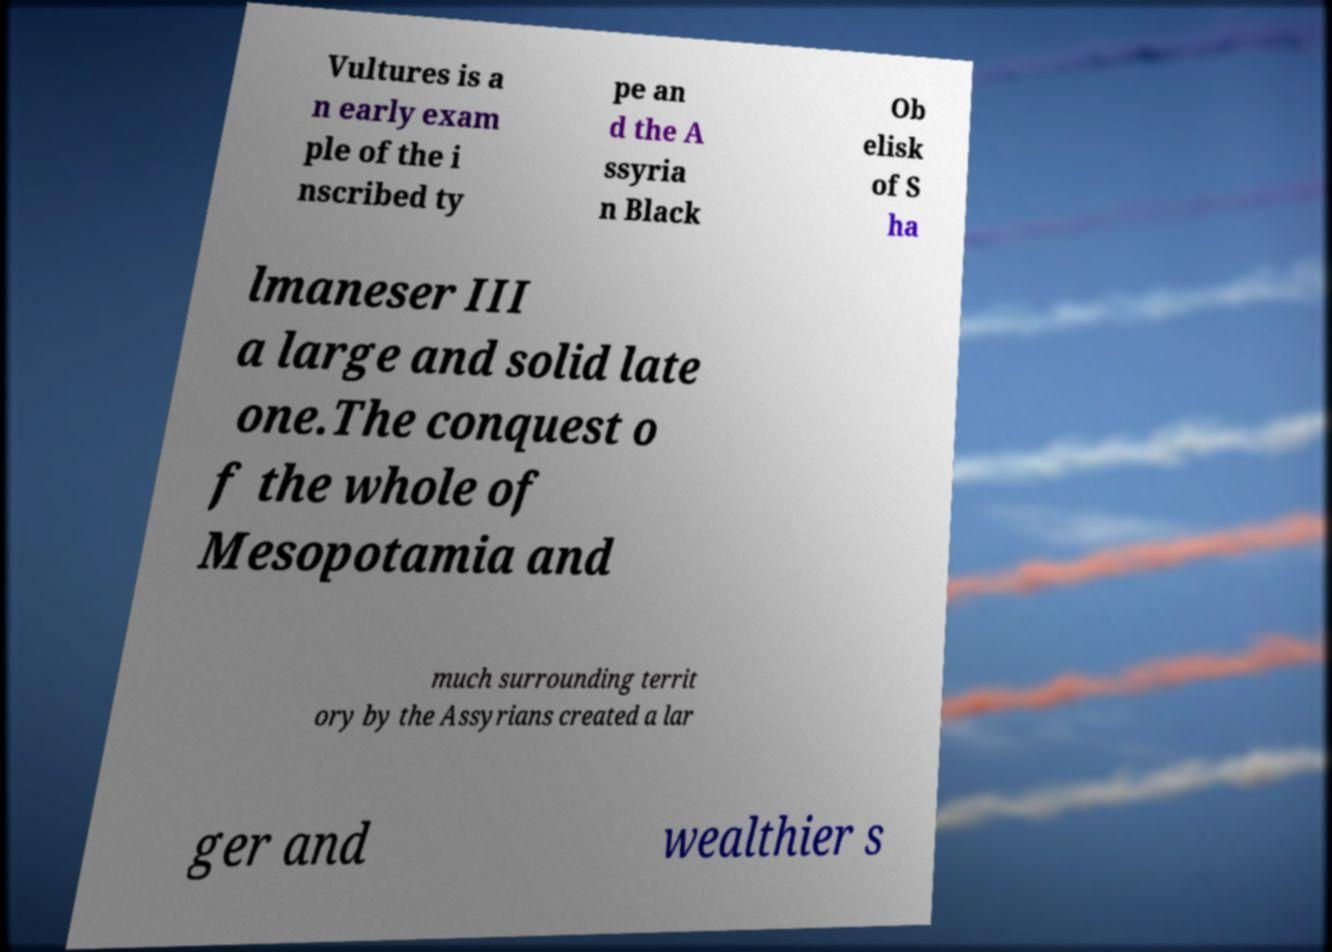Could you extract and type out the text from this image? Vultures is a n early exam ple of the i nscribed ty pe an d the A ssyria n Black Ob elisk of S ha lmaneser III a large and solid late one.The conquest o f the whole of Mesopotamia and much surrounding territ ory by the Assyrians created a lar ger and wealthier s 